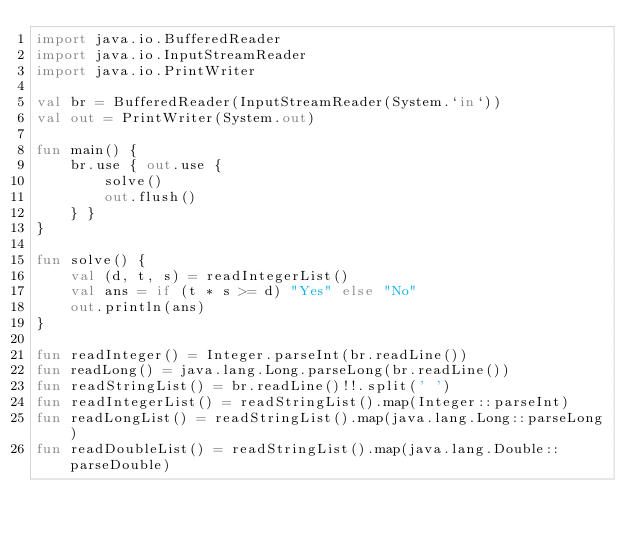<code> <loc_0><loc_0><loc_500><loc_500><_Kotlin_>import java.io.BufferedReader
import java.io.InputStreamReader
import java.io.PrintWriter

val br = BufferedReader(InputStreamReader(System.`in`))
val out = PrintWriter(System.out)

fun main() {
    br.use { out.use {
        solve()
        out.flush()
    } }
}

fun solve() {
    val (d, t, s) = readIntegerList()
    val ans = if (t * s >= d) "Yes" else "No"
    out.println(ans)
}

fun readInteger() = Integer.parseInt(br.readLine())
fun readLong() = java.lang.Long.parseLong(br.readLine())
fun readStringList() = br.readLine()!!.split(' ')
fun readIntegerList() = readStringList().map(Integer::parseInt)
fun readLongList() = readStringList().map(java.lang.Long::parseLong)
fun readDoubleList() = readStringList().map(java.lang.Double::parseDouble)
</code> 